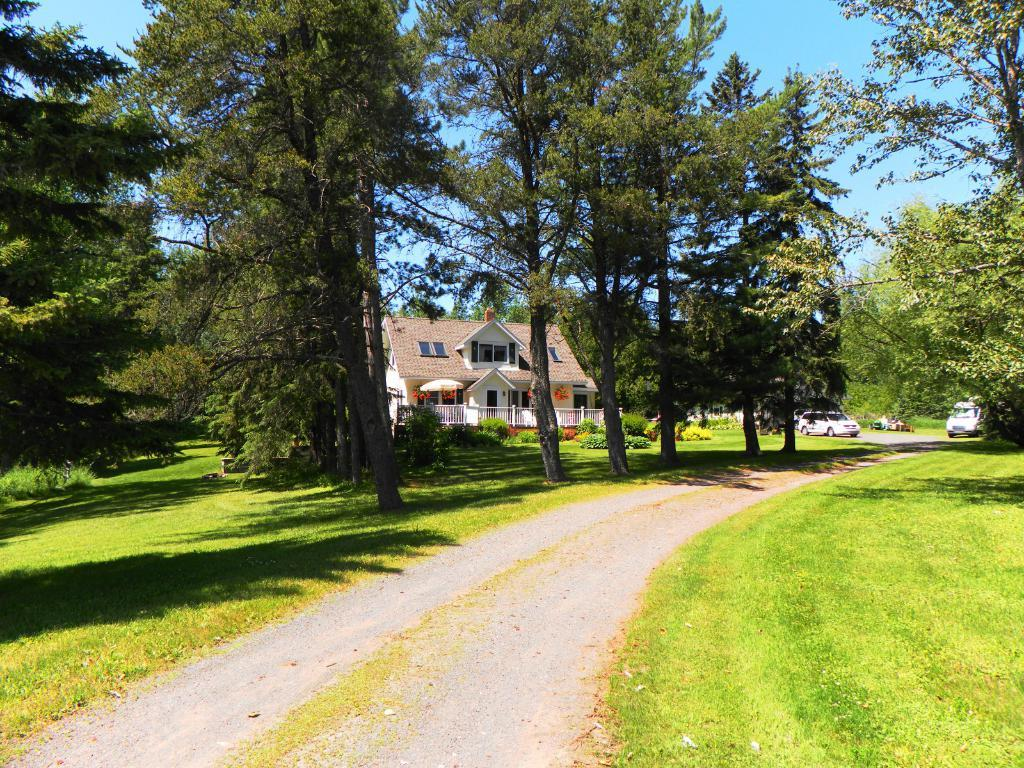What can be seen on the road in the image? There are vehicles on the road in the image. What is visible in the background of the image? The sky, trees, grass, plants, a building, a wall, a roof, a door, and a fence are visible in the background of the image. How many books are stacked on the donkey in the image? There is no donkey or books present in the image. 